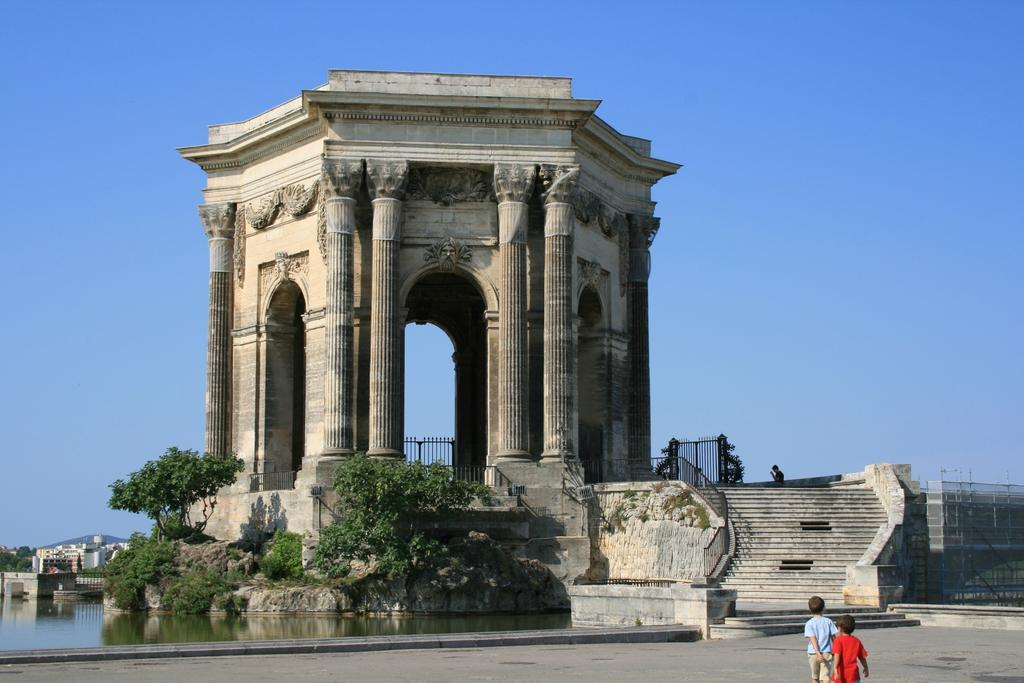What location is depicted in the image? The image depicts Plaza Real Del Peyrou. What natural element can be seen in the image? There is water in the image. What type of vegetation is present in the image? There are trees in the image. What man-made structures are visible in the image? There are buildings in the image. What architectural feature can be seen in the image? Iron grilles are present in the image. What type of terrain is visible in the image? There are stairs in the image. Who or what is present in the image? Two kids are standing in the image. What is visible in the background of the image? The sky is visible in the background of the image. What type of pencil can be seen in the hands of the kids in the image? There are no pencils present in the image; the kids are not holding any objects. 